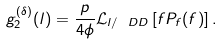Convert formula to latex. <formula><loc_0><loc_0><loc_500><loc_500>g _ { 2 } ^ { ( \delta ) } ( l ) = \frac { p } { 4 \phi } \mathcal { L } _ { l / \ D { D } } \left [ f P _ { f } ( f ) \right ] .</formula> 